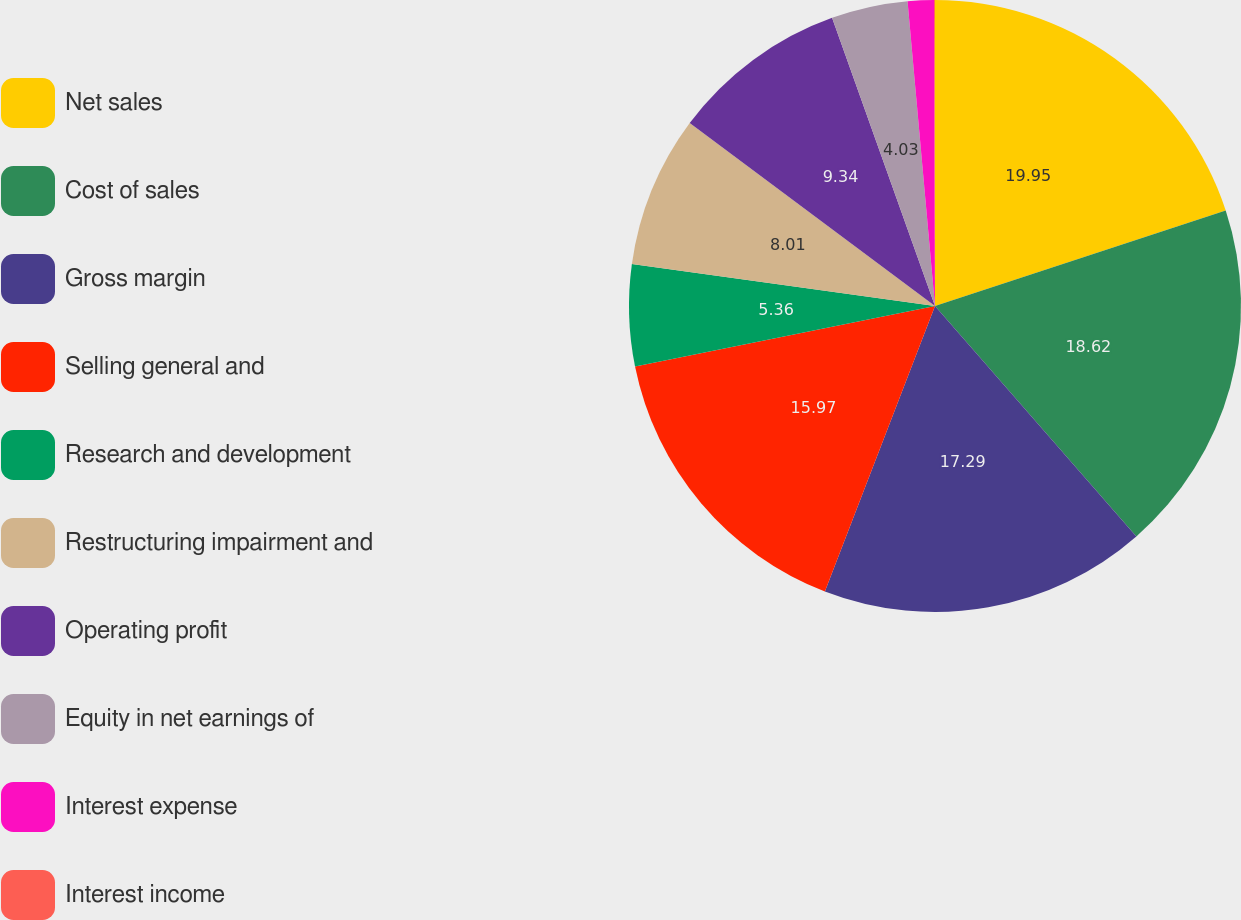<chart> <loc_0><loc_0><loc_500><loc_500><pie_chart><fcel>Net sales<fcel>Cost of sales<fcel>Gross margin<fcel>Selling general and<fcel>Research and development<fcel>Restructuring impairment and<fcel>Operating profit<fcel>Equity in net earnings of<fcel>Interest expense<fcel>Interest income<nl><fcel>19.95%<fcel>18.62%<fcel>17.29%<fcel>15.97%<fcel>5.36%<fcel>8.01%<fcel>9.34%<fcel>4.03%<fcel>1.38%<fcel>0.05%<nl></chart> 